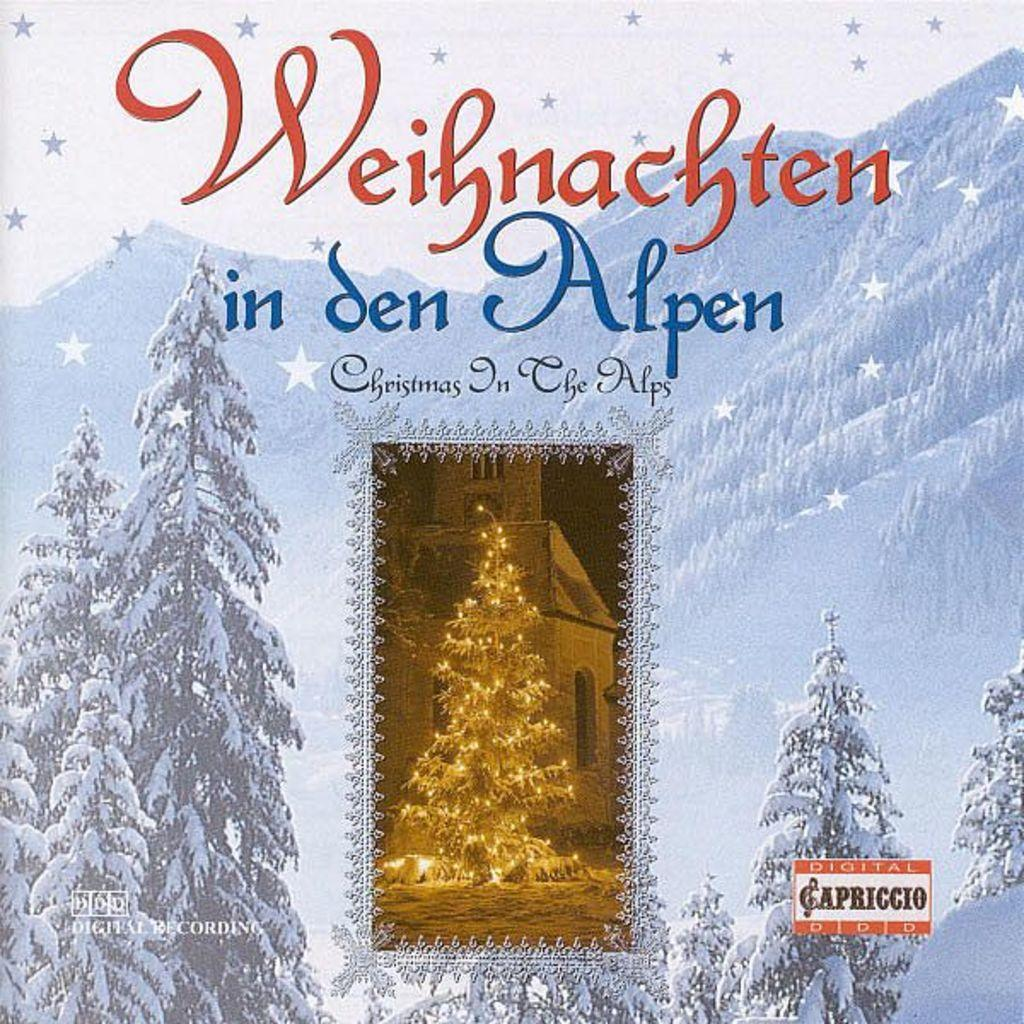What type of visual representation is shown in the image? The image is a poster. What natural elements are depicted in the poster? There are trees and mountains in the poster. What type of structure is present in the poster? There is a building with windows in the poster. What seasonal decoration can be seen on the ground in the poster? There is a Christmas tree on the ground in the poster. How many times has the beginner climbed the mountain in the poster? There is no indication of a beginner or any climbing activity in the poster. 